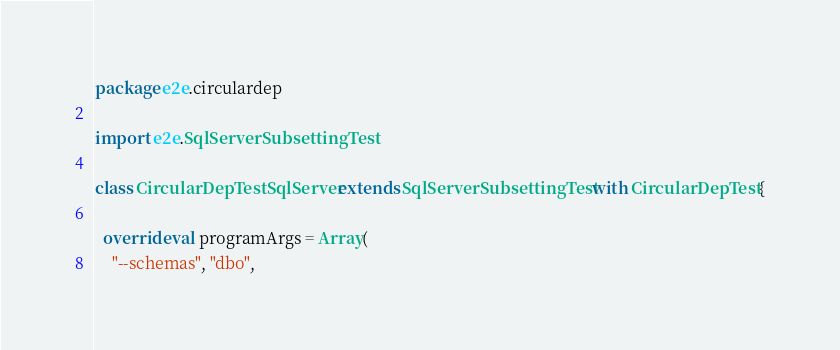<code> <loc_0><loc_0><loc_500><loc_500><_Scala_>package e2e.circulardep

import e2e.SqlServerSubsettingTest

class CircularDepTestSqlServer extends SqlServerSubsettingTest with CircularDepTest {

  override val programArgs = Array(
    "--schemas", "dbo",</code> 